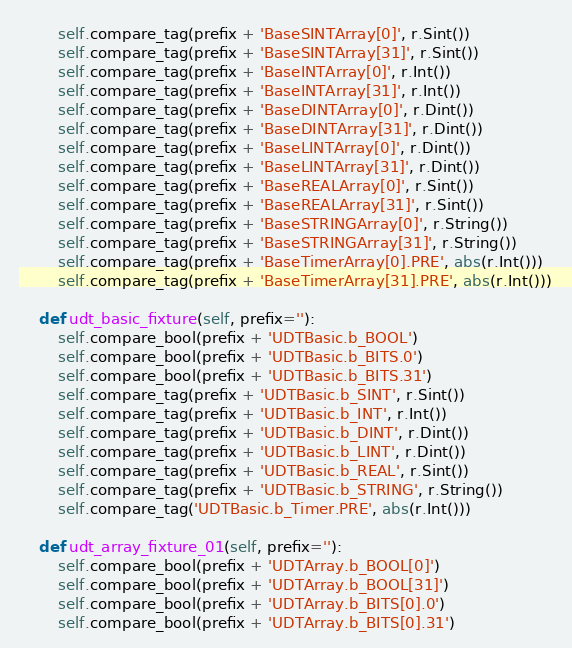<code> <loc_0><loc_0><loc_500><loc_500><_Python_>        self.compare_tag(prefix + 'BaseSINTArray[0]', r.Sint())
        self.compare_tag(prefix + 'BaseSINTArray[31]', r.Sint())
        self.compare_tag(prefix + 'BaseINTArray[0]', r.Int())
        self.compare_tag(prefix + 'BaseINTArray[31]', r.Int())
        self.compare_tag(prefix + 'BaseDINTArray[0]', r.Dint())
        self.compare_tag(prefix + 'BaseDINTArray[31]', r.Dint())
        self.compare_tag(prefix + 'BaseLINTArray[0]', r.Dint())
        self.compare_tag(prefix + 'BaseLINTArray[31]', r.Dint())
        self.compare_tag(prefix + 'BaseREALArray[0]', r.Sint())
        self.compare_tag(prefix + 'BaseREALArray[31]', r.Sint())
        self.compare_tag(prefix + 'BaseSTRINGArray[0]', r.String())
        self.compare_tag(prefix + 'BaseSTRINGArray[31]', r.String())
        self.compare_tag(prefix + 'BaseTimerArray[0].PRE', abs(r.Int()))
        self.compare_tag(prefix + 'BaseTimerArray[31].PRE', abs(r.Int()))

    def udt_basic_fixture(self, prefix=''):
        self.compare_bool(prefix + 'UDTBasic.b_BOOL')
        self.compare_bool(prefix + 'UDTBasic.b_BITS.0')
        self.compare_bool(prefix + 'UDTBasic.b_BITS.31')
        self.compare_tag(prefix + 'UDTBasic.b_SINT', r.Sint())
        self.compare_tag(prefix + 'UDTBasic.b_INT', r.Int())
        self.compare_tag(prefix + 'UDTBasic.b_DINT', r.Dint())
        self.compare_tag(prefix + 'UDTBasic.b_LINT', r.Dint())
        self.compare_tag(prefix + 'UDTBasic.b_REAL', r.Sint())
        self.compare_tag(prefix + 'UDTBasic.b_STRING', r.String())
        self.compare_tag('UDTBasic.b_Timer.PRE', abs(r.Int()))

    def udt_array_fixture_01(self, prefix=''):
        self.compare_bool(prefix + 'UDTArray.b_BOOL[0]')
        self.compare_bool(prefix + 'UDTArray.b_BOOL[31]')
        self.compare_bool(prefix + 'UDTArray.b_BITS[0].0')
        self.compare_bool(prefix + 'UDTArray.b_BITS[0].31')</code> 